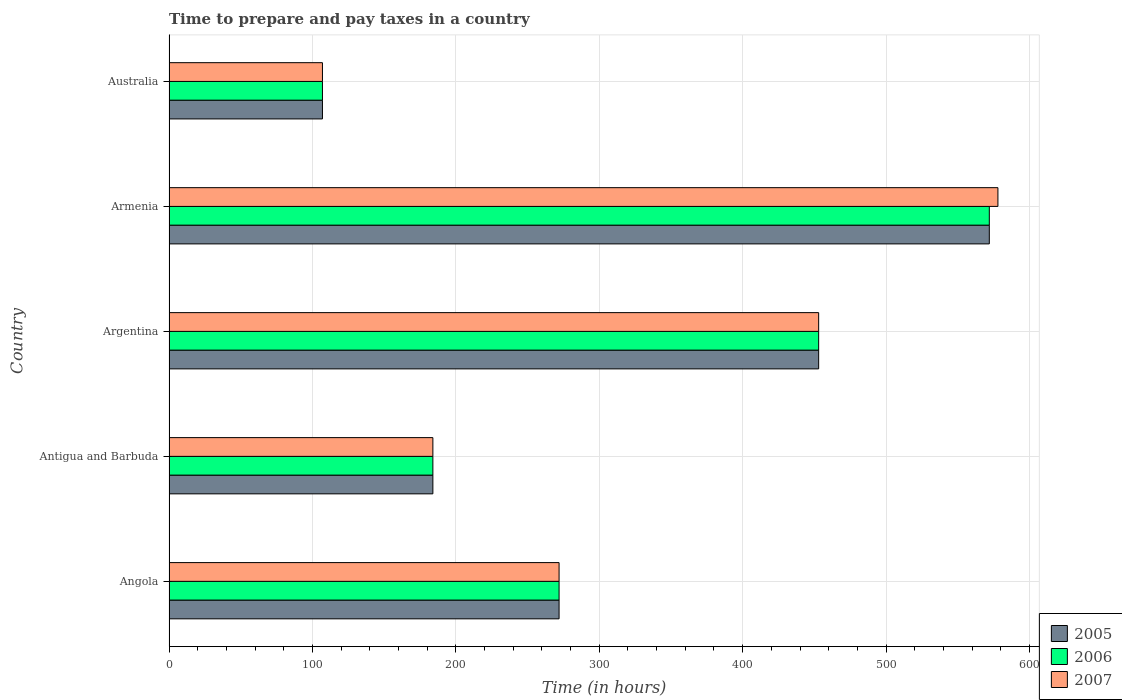How many different coloured bars are there?
Your answer should be compact. 3. Are the number of bars per tick equal to the number of legend labels?
Your response must be concise. Yes. Are the number of bars on each tick of the Y-axis equal?
Your answer should be compact. Yes. How many bars are there on the 4th tick from the top?
Give a very brief answer. 3. How many bars are there on the 3rd tick from the bottom?
Provide a short and direct response. 3. What is the label of the 5th group of bars from the top?
Your response must be concise. Angola. What is the number of hours required to prepare and pay taxes in 2005 in Angola?
Your answer should be very brief. 272. Across all countries, what is the maximum number of hours required to prepare and pay taxes in 2005?
Your response must be concise. 572. Across all countries, what is the minimum number of hours required to prepare and pay taxes in 2007?
Provide a short and direct response. 107. In which country was the number of hours required to prepare and pay taxes in 2006 maximum?
Your response must be concise. Armenia. In which country was the number of hours required to prepare and pay taxes in 2005 minimum?
Offer a very short reply. Australia. What is the total number of hours required to prepare and pay taxes in 2007 in the graph?
Offer a terse response. 1594. What is the difference between the number of hours required to prepare and pay taxes in 2005 in Angola and that in Armenia?
Provide a short and direct response. -300. What is the difference between the number of hours required to prepare and pay taxes in 2006 in Australia and the number of hours required to prepare and pay taxes in 2007 in Angola?
Provide a succinct answer. -165. What is the average number of hours required to prepare and pay taxes in 2006 per country?
Offer a terse response. 317.6. What is the difference between the number of hours required to prepare and pay taxes in 2006 and number of hours required to prepare and pay taxes in 2007 in Argentina?
Ensure brevity in your answer.  0. In how many countries, is the number of hours required to prepare and pay taxes in 2007 greater than 480 hours?
Your answer should be very brief. 1. What is the ratio of the number of hours required to prepare and pay taxes in 2007 in Angola to that in Armenia?
Make the answer very short. 0.47. Is the number of hours required to prepare and pay taxes in 2006 in Angola less than that in Armenia?
Keep it short and to the point. Yes. What is the difference between the highest and the second highest number of hours required to prepare and pay taxes in 2006?
Make the answer very short. 119. What is the difference between the highest and the lowest number of hours required to prepare and pay taxes in 2007?
Offer a very short reply. 471. What does the 3rd bar from the top in Argentina represents?
Offer a very short reply. 2005. What does the 1st bar from the bottom in Australia represents?
Offer a very short reply. 2005. How many bars are there?
Make the answer very short. 15. How many countries are there in the graph?
Ensure brevity in your answer.  5. Does the graph contain any zero values?
Your answer should be very brief. No. What is the title of the graph?
Your answer should be very brief. Time to prepare and pay taxes in a country. What is the label or title of the X-axis?
Your answer should be compact. Time (in hours). What is the label or title of the Y-axis?
Provide a succinct answer. Country. What is the Time (in hours) of 2005 in Angola?
Provide a short and direct response. 272. What is the Time (in hours) in 2006 in Angola?
Keep it short and to the point. 272. What is the Time (in hours) of 2007 in Angola?
Your answer should be very brief. 272. What is the Time (in hours) in 2005 in Antigua and Barbuda?
Give a very brief answer. 184. What is the Time (in hours) in 2006 in Antigua and Barbuda?
Keep it short and to the point. 184. What is the Time (in hours) of 2007 in Antigua and Barbuda?
Your response must be concise. 184. What is the Time (in hours) of 2005 in Argentina?
Make the answer very short. 453. What is the Time (in hours) in 2006 in Argentina?
Offer a terse response. 453. What is the Time (in hours) of 2007 in Argentina?
Provide a short and direct response. 453. What is the Time (in hours) of 2005 in Armenia?
Your answer should be very brief. 572. What is the Time (in hours) of 2006 in Armenia?
Keep it short and to the point. 572. What is the Time (in hours) of 2007 in Armenia?
Keep it short and to the point. 578. What is the Time (in hours) of 2005 in Australia?
Make the answer very short. 107. What is the Time (in hours) in 2006 in Australia?
Provide a short and direct response. 107. What is the Time (in hours) in 2007 in Australia?
Ensure brevity in your answer.  107. Across all countries, what is the maximum Time (in hours) of 2005?
Make the answer very short. 572. Across all countries, what is the maximum Time (in hours) of 2006?
Give a very brief answer. 572. Across all countries, what is the maximum Time (in hours) of 2007?
Give a very brief answer. 578. Across all countries, what is the minimum Time (in hours) of 2005?
Provide a succinct answer. 107. Across all countries, what is the minimum Time (in hours) in 2006?
Keep it short and to the point. 107. Across all countries, what is the minimum Time (in hours) in 2007?
Your response must be concise. 107. What is the total Time (in hours) in 2005 in the graph?
Provide a succinct answer. 1588. What is the total Time (in hours) in 2006 in the graph?
Offer a very short reply. 1588. What is the total Time (in hours) in 2007 in the graph?
Your answer should be compact. 1594. What is the difference between the Time (in hours) in 2005 in Angola and that in Antigua and Barbuda?
Provide a short and direct response. 88. What is the difference between the Time (in hours) of 2007 in Angola and that in Antigua and Barbuda?
Keep it short and to the point. 88. What is the difference between the Time (in hours) in 2005 in Angola and that in Argentina?
Provide a short and direct response. -181. What is the difference between the Time (in hours) of 2006 in Angola and that in Argentina?
Offer a very short reply. -181. What is the difference between the Time (in hours) in 2007 in Angola and that in Argentina?
Your answer should be very brief. -181. What is the difference between the Time (in hours) in 2005 in Angola and that in Armenia?
Provide a short and direct response. -300. What is the difference between the Time (in hours) in 2006 in Angola and that in Armenia?
Your response must be concise. -300. What is the difference between the Time (in hours) in 2007 in Angola and that in Armenia?
Provide a short and direct response. -306. What is the difference between the Time (in hours) of 2005 in Angola and that in Australia?
Ensure brevity in your answer.  165. What is the difference between the Time (in hours) of 2006 in Angola and that in Australia?
Offer a terse response. 165. What is the difference between the Time (in hours) of 2007 in Angola and that in Australia?
Give a very brief answer. 165. What is the difference between the Time (in hours) in 2005 in Antigua and Barbuda and that in Argentina?
Your answer should be compact. -269. What is the difference between the Time (in hours) in 2006 in Antigua and Barbuda and that in Argentina?
Give a very brief answer. -269. What is the difference between the Time (in hours) of 2007 in Antigua and Barbuda and that in Argentina?
Your answer should be compact. -269. What is the difference between the Time (in hours) of 2005 in Antigua and Barbuda and that in Armenia?
Give a very brief answer. -388. What is the difference between the Time (in hours) of 2006 in Antigua and Barbuda and that in Armenia?
Provide a short and direct response. -388. What is the difference between the Time (in hours) of 2007 in Antigua and Barbuda and that in Armenia?
Provide a succinct answer. -394. What is the difference between the Time (in hours) in 2005 in Antigua and Barbuda and that in Australia?
Your answer should be very brief. 77. What is the difference between the Time (in hours) of 2005 in Argentina and that in Armenia?
Keep it short and to the point. -119. What is the difference between the Time (in hours) in 2006 in Argentina and that in Armenia?
Ensure brevity in your answer.  -119. What is the difference between the Time (in hours) of 2007 in Argentina and that in Armenia?
Keep it short and to the point. -125. What is the difference between the Time (in hours) in 2005 in Argentina and that in Australia?
Provide a short and direct response. 346. What is the difference between the Time (in hours) of 2006 in Argentina and that in Australia?
Your answer should be very brief. 346. What is the difference between the Time (in hours) of 2007 in Argentina and that in Australia?
Your answer should be compact. 346. What is the difference between the Time (in hours) of 2005 in Armenia and that in Australia?
Your answer should be compact. 465. What is the difference between the Time (in hours) in 2006 in Armenia and that in Australia?
Offer a very short reply. 465. What is the difference between the Time (in hours) in 2007 in Armenia and that in Australia?
Your response must be concise. 471. What is the difference between the Time (in hours) of 2005 in Angola and the Time (in hours) of 2006 in Antigua and Barbuda?
Your response must be concise. 88. What is the difference between the Time (in hours) in 2005 in Angola and the Time (in hours) in 2007 in Antigua and Barbuda?
Offer a very short reply. 88. What is the difference between the Time (in hours) in 2006 in Angola and the Time (in hours) in 2007 in Antigua and Barbuda?
Offer a very short reply. 88. What is the difference between the Time (in hours) of 2005 in Angola and the Time (in hours) of 2006 in Argentina?
Give a very brief answer. -181. What is the difference between the Time (in hours) in 2005 in Angola and the Time (in hours) in 2007 in Argentina?
Ensure brevity in your answer.  -181. What is the difference between the Time (in hours) of 2006 in Angola and the Time (in hours) of 2007 in Argentina?
Provide a succinct answer. -181. What is the difference between the Time (in hours) of 2005 in Angola and the Time (in hours) of 2006 in Armenia?
Offer a very short reply. -300. What is the difference between the Time (in hours) of 2005 in Angola and the Time (in hours) of 2007 in Armenia?
Provide a succinct answer. -306. What is the difference between the Time (in hours) of 2006 in Angola and the Time (in hours) of 2007 in Armenia?
Keep it short and to the point. -306. What is the difference between the Time (in hours) of 2005 in Angola and the Time (in hours) of 2006 in Australia?
Give a very brief answer. 165. What is the difference between the Time (in hours) in 2005 in Angola and the Time (in hours) in 2007 in Australia?
Provide a short and direct response. 165. What is the difference between the Time (in hours) in 2006 in Angola and the Time (in hours) in 2007 in Australia?
Ensure brevity in your answer.  165. What is the difference between the Time (in hours) of 2005 in Antigua and Barbuda and the Time (in hours) of 2006 in Argentina?
Your answer should be very brief. -269. What is the difference between the Time (in hours) in 2005 in Antigua and Barbuda and the Time (in hours) in 2007 in Argentina?
Your answer should be compact. -269. What is the difference between the Time (in hours) of 2006 in Antigua and Barbuda and the Time (in hours) of 2007 in Argentina?
Provide a short and direct response. -269. What is the difference between the Time (in hours) of 2005 in Antigua and Barbuda and the Time (in hours) of 2006 in Armenia?
Provide a succinct answer. -388. What is the difference between the Time (in hours) of 2005 in Antigua and Barbuda and the Time (in hours) of 2007 in Armenia?
Your answer should be compact. -394. What is the difference between the Time (in hours) of 2006 in Antigua and Barbuda and the Time (in hours) of 2007 in Armenia?
Make the answer very short. -394. What is the difference between the Time (in hours) of 2005 in Argentina and the Time (in hours) of 2006 in Armenia?
Make the answer very short. -119. What is the difference between the Time (in hours) in 2005 in Argentina and the Time (in hours) in 2007 in Armenia?
Give a very brief answer. -125. What is the difference between the Time (in hours) in 2006 in Argentina and the Time (in hours) in 2007 in Armenia?
Ensure brevity in your answer.  -125. What is the difference between the Time (in hours) in 2005 in Argentina and the Time (in hours) in 2006 in Australia?
Provide a succinct answer. 346. What is the difference between the Time (in hours) of 2005 in Argentina and the Time (in hours) of 2007 in Australia?
Give a very brief answer. 346. What is the difference between the Time (in hours) in 2006 in Argentina and the Time (in hours) in 2007 in Australia?
Keep it short and to the point. 346. What is the difference between the Time (in hours) of 2005 in Armenia and the Time (in hours) of 2006 in Australia?
Give a very brief answer. 465. What is the difference between the Time (in hours) in 2005 in Armenia and the Time (in hours) in 2007 in Australia?
Your answer should be very brief. 465. What is the difference between the Time (in hours) in 2006 in Armenia and the Time (in hours) in 2007 in Australia?
Offer a terse response. 465. What is the average Time (in hours) in 2005 per country?
Keep it short and to the point. 317.6. What is the average Time (in hours) in 2006 per country?
Provide a short and direct response. 317.6. What is the average Time (in hours) in 2007 per country?
Provide a succinct answer. 318.8. What is the difference between the Time (in hours) in 2005 and Time (in hours) in 2006 in Angola?
Your response must be concise. 0. What is the difference between the Time (in hours) of 2005 and Time (in hours) of 2007 in Angola?
Provide a succinct answer. 0. What is the difference between the Time (in hours) in 2006 and Time (in hours) in 2007 in Angola?
Your response must be concise. 0. What is the difference between the Time (in hours) of 2005 and Time (in hours) of 2006 in Antigua and Barbuda?
Provide a succinct answer. 0. What is the difference between the Time (in hours) of 2006 and Time (in hours) of 2007 in Antigua and Barbuda?
Ensure brevity in your answer.  0. What is the difference between the Time (in hours) in 2005 and Time (in hours) in 2006 in Argentina?
Offer a very short reply. 0. What is the difference between the Time (in hours) in 2006 and Time (in hours) in 2007 in Argentina?
Provide a succinct answer. 0. What is the difference between the Time (in hours) in 2005 and Time (in hours) in 2006 in Armenia?
Offer a very short reply. 0. What is the difference between the Time (in hours) of 2006 and Time (in hours) of 2007 in Armenia?
Provide a short and direct response. -6. What is the difference between the Time (in hours) of 2005 and Time (in hours) of 2006 in Australia?
Your answer should be compact. 0. What is the difference between the Time (in hours) in 2005 and Time (in hours) in 2007 in Australia?
Give a very brief answer. 0. What is the ratio of the Time (in hours) in 2005 in Angola to that in Antigua and Barbuda?
Your answer should be compact. 1.48. What is the ratio of the Time (in hours) of 2006 in Angola to that in Antigua and Barbuda?
Your answer should be compact. 1.48. What is the ratio of the Time (in hours) in 2007 in Angola to that in Antigua and Barbuda?
Provide a succinct answer. 1.48. What is the ratio of the Time (in hours) of 2005 in Angola to that in Argentina?
Offer a terse response. 0.6. What is the ratio of the Time (in hours) of 2006 in Angola to that in Argentina?
Make the answer very short. 0.6. What is the ratio of the Time (in hours) in 2007 in Angola to that in Argentina?
Offer a terse response. 0.6. What is the ratio of the Time (in hours) in 2005 in Angola to that in Armenia?
Provide a short and direct response. 0.48. What is the ratio of the Time (in hours) in 2006 in Angola to that in Armenia?
Your answer should be compact. 0.48. What is the ratio of the Time (in hours) of 2007 in Angola to that in Armenia?
Give a very brief answer. 0.47. What is the ratio of the Time (in hours) in 2005 in Angola to that in Australia?
Offer a very short reply. 2.54. What is the ratio of the Time (in hours) of 2006 in Angola to that in Australia?
Your answer should be compact. 2.54. What is the ratio of the Time (in hours) of 2007 in Angola to that in Australia?
Your answer should be very brief. 2.54. What is the ratio of the Time (in hours) of 2005 in Antigua and Barbuda to that in Argentina?
Keep it short and to the point. 0.41. What is the ratio of the Time (in hours) of 2006 in Antigua and Barbuda to that in Argentina?
Ensure brevity in your answer.  0.41. What is the ratio of the Time (in hours) of 2007 in Antigua and Barbuda to that in Argentina?
Offer a terse response. 0.41. What is the ratio of the Time (in hours) of 2005 in Antigua and Barbuda to that in Armenia?
Your response must be concise. 0.32. What is the ratio of the Time (in hours) of 2006 in Antigua and Barbuda to that in Armenia?
Offer a terse response. 0.32. What is the ratio of the Time (in hours) of 2007 in Antigua and Barbuda to that in Armenia?
Your answer should be compact. 0.32. What is the ratio of the Time (in hours) of 2005 in Antigua and Barbuda to that in Australia?
Offer a very short reply. 1.72. What is the ratio of the Time (in hours) in 2006 in Antigua and Barbuda to that in Australia?
Your answer should be very brief. 1.72. What is the ratio of the Time (in hours) of 2007 in Antigua and Barbuda to that in Australia?
Ensure brevity in your answer.  1.72. What is the ratio of the Time (in hours) in 2005 in Argentina to that in Armenia?
Your answer should be very brief. 0.79. What is the ratio of the Time (in hours) in 2006 in Argentina to that in Armenia?
Provide a succinct answer. 0.79. What is the ratio of the Time (in hours) in 2007 in Argentina to that in Armenia?
Provide a short and direct response. 0.78. What is the ratio of the Time (in hours) in 2005 in Argentina to that in Australia?
Your answer should be very brief. 4.23. What is the ratio of the Time (in hours) in 2006 in Argentina to that in Australia?
Offer a terse response. 4.23. What is the ratio of the Time (in hours) of 2007 in Argentina to that in Australia?
Provide a short and direct response. 4.23. What is the ratio of the Time (in hours) in 2005 in Armenia to that in Australia?
Give a very brief answer. 5.35. What is the ratio of the Time (in hours) of 2006 in Armenia to that in Australia?
Make the answer very short. 5.35. What is the ratio of the Time (in hours) of 2007 in Armenia to that in Australia?
Give a very brief answer. 5.4. What is the difference between the highest and the second highest Time (in hours) of 2005?
Offer a terse response. 119. What is the difference between the highest and the second highest Time (in hours) of 2006?
Your answer should be very brief. 119. What is the difference between the highest and the second highest Time (in hours) in 2007?
Your answer should be compact. 125. What is the difference between the highest and the lowest Time (in hours) in 2005?
Make the answer very short. 465. What is the difference between the highest and the lowest Time (in hours) in 2006?
Offer a very short reply. 465. What is the difference between the highest and the lowest Time (in hours) in 2007?
Keep it short and to the point. 471. 